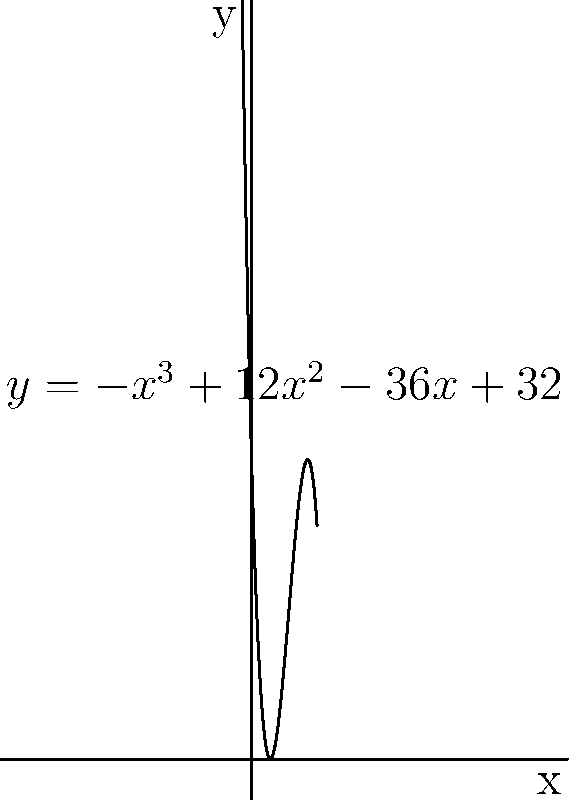As a pediatrician, you're developing a new drug formulation for children. The concentration of the active ingredient in the bloodstream over time can be modeled by the function $f(x) = -x^3 + 12x^2 - 36x + 32$, where $x$ is the time in hours and $f(x)$ is the concentration in mg/L. What is the optimal time (in hours) to administer the next dose, assuming it's best to give the dose when the concentration reaches zero? To find the optimal time to administer the next dose, we need to find the roots of the polynomial equation:

$f(x) = -x^3 + 12x^2 - 36x + 32 = 0$

This is a cubic equation. We can solve it using the following steps:

1) First, let's check if there's an obvious root. We can see that when $x = 2$, the equation becomes:
   $-8 + 48 - 72 + 32 = 0$

2) So, $x = 2$ is one root. We can factor it out:
   $-(x - 2)(x^2 - 10x + 16) = 0$

3) Now we have a quadratic equation to solve: $x^2 - 10x + 16 = 0$

4) We can solve this using the quadratic formula: $x = \frac{-b \pm \sqrt{b^2 - 4ac}}{2a}$

   Where $a = 1$, $b = -10$, and $c = 16$

5) Plugging in these values:
   $x = \frac{10 \pm \sqrt{100 - 64}}{2} = \frac{10 \pm 6}{2}$

6) This gives us two more roots:
   $x = 8$ or $x = 2$

Therefore, the roots are 2, 2, and 8. The optimal time to administer the next dose is at the latest root, which is 8 hours after the initial dose.
Answer: 8 hours 